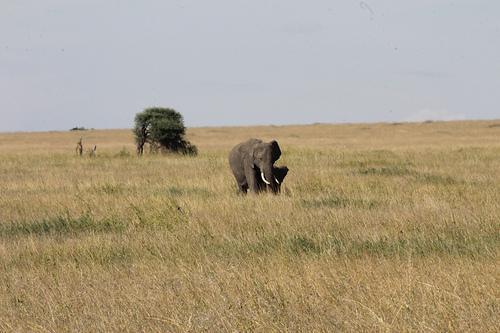How many trees are in the picture?
Give a very brief answer. 1. How many animals are here?
Give a very brief answer. 2. 